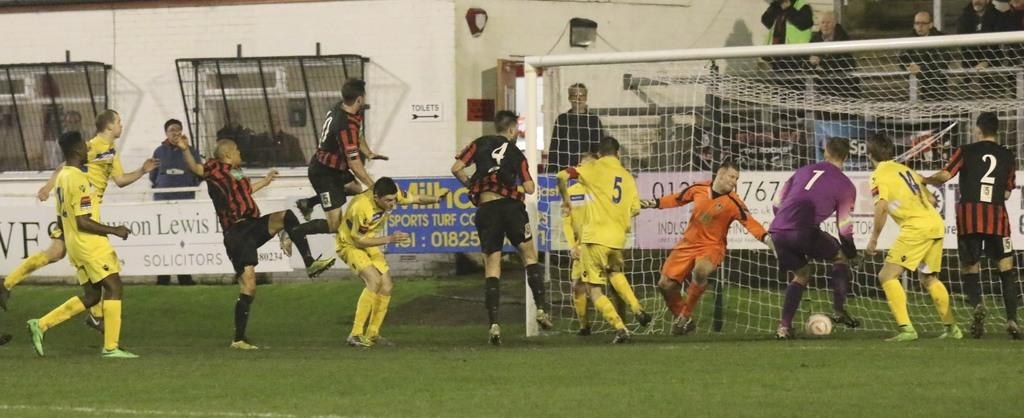Provide a one-sentence caption for the provided image. Soccer players playing soccer in fron of a sign for sports turf. 